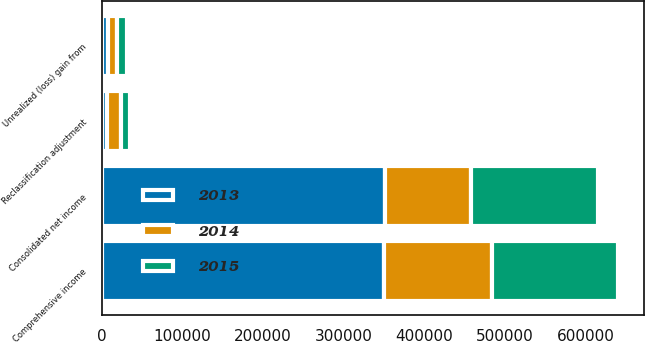Convert chart. <chart><loc_0><loc_0><loc_500><loc_500><stacked_bar_chart><ecel><fcel>Consolidated net income<fcel>Unrealized (loss) gain from<fcel>Reclassification adjustment<fcel>Comprehensive income<nl><fcel>2013<fcel>350745<fcel>8306<fcel>7064<fcel>349503<nl><fcel>2015<fcel>156277<fcel>12335<fcel>11785<fcel>155727<nl><fcel>2014<fcel>107544<fcel>10684<fcel>16370<fcel>134598<nl></chart> 